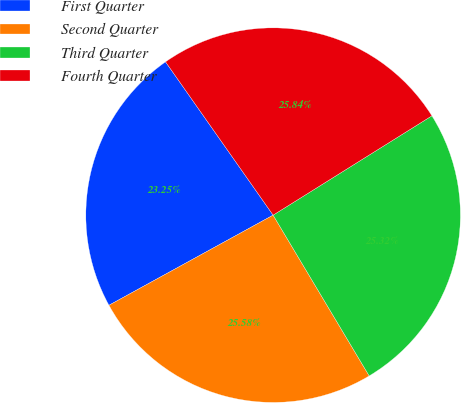Convert chart. <chart><loc_0><loc_0><loc_500><loc_500><pie_chart><fcel>First Quarter<fcel>Second Quarter<fcel>Third Quarter<fcel>Fourth Quarter<nl><fcel>23.25%<fcel>25.58%<fcel>25.32%<fcel>25.84%<nl></chart> 